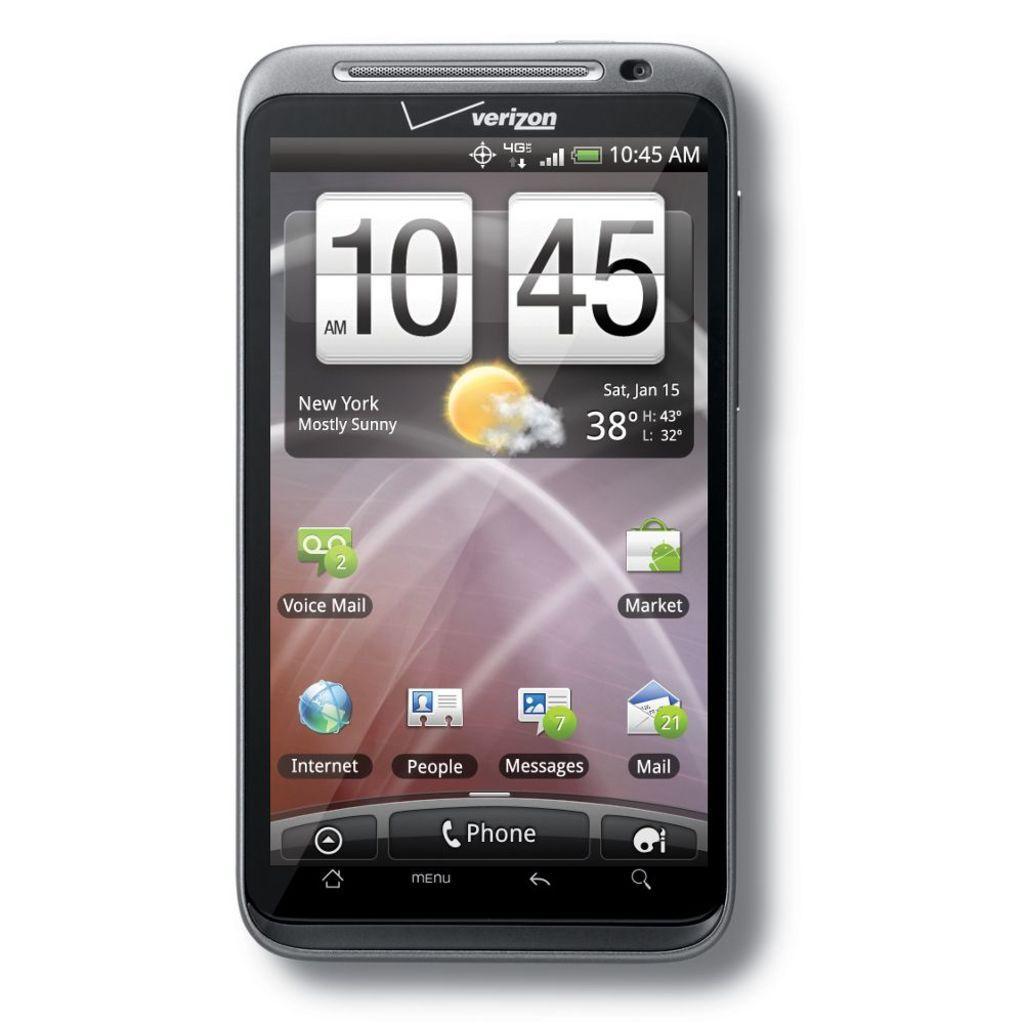How would you summarize this image in a sentence or two? In the image there is a mobile. On the mobile screen there are icons, time, temperature and there are some other things on it. 